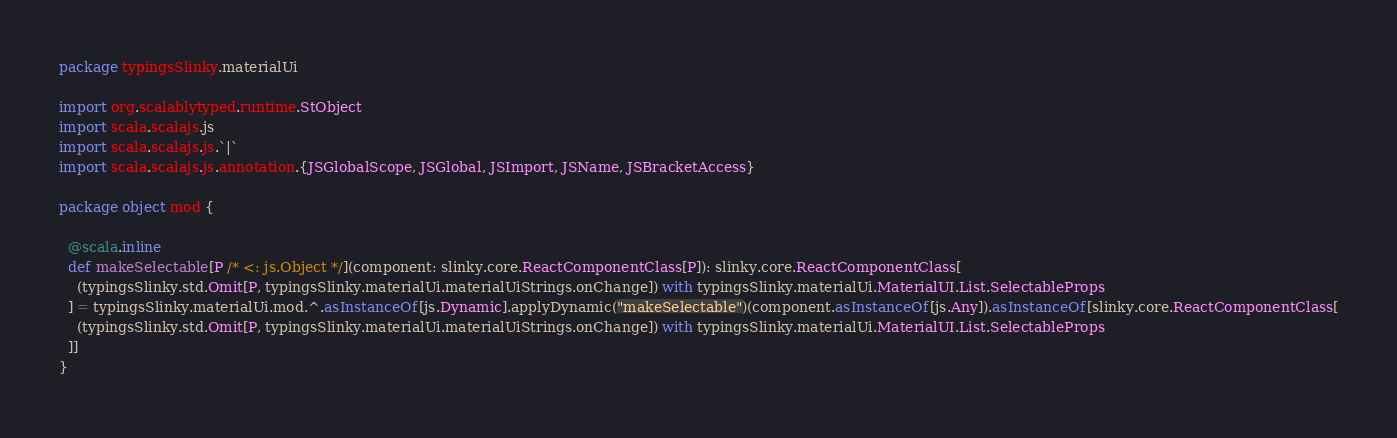Convert code to text. <code><loc_0><loc_0><loc_500><loc_500><_Scala_>package typingsSlinky.materialUi

import org.scalablytyped.runtime.StObject
import scala.scalajs.js
import scala.scalajs.js.`|`
import scala.scalajs.js.annotation.{JSGlobalScope, JSGlobal, JSImport, JSName, JSBracketAccess}

package object mod {
  
  @scala.inline
  def makeSelectable[P /* <: js.Object */](component: slinky.core.ReactComponentClass[P]): slinky.core.ReactComponentClass[
    (typingsSlinky.std.Omit[P, typingsSlinky.materialUi.materialUiStrings.onChange]) with typingsSlinky.materialUi.MaterialUI.List.SelectableProps
  ] = typingsSlinky.materialUi.mod.^.asInstanceOf[js.Dynamic].applyDynamic("makeSelectable")(component.asInstanceOf[js.Any]).asInstanceOf[slinky.core.ReactComponentClass[
    (typingsSlinky.std.Omit[P, typingsSlinky.materialUi.materialUiStrings.onChange]) with typingsSlinky.materialUi.MaterialUI.List.SelectableProps
  ]]
}
</code> 